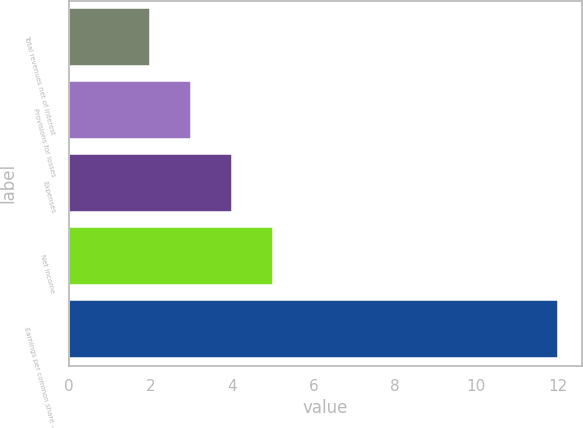Convert chart to OTSL. <chart><loc_0><loc_0><loc_500><loc_500><bar_chart><fcel>Total revenues net of interest<fcel>Provisions for losses<fcel>Expenses<fcel>Net income<fcel>Earnings per common share -<nl><fcel>2<fcel>3<fcel>4<fcel>5<fcel>12<nl></chart> 